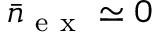<formula> <loc_0><loc_0><loc_500><loc_500>\bar { n } _ { e x } \simeq 0</formula> 